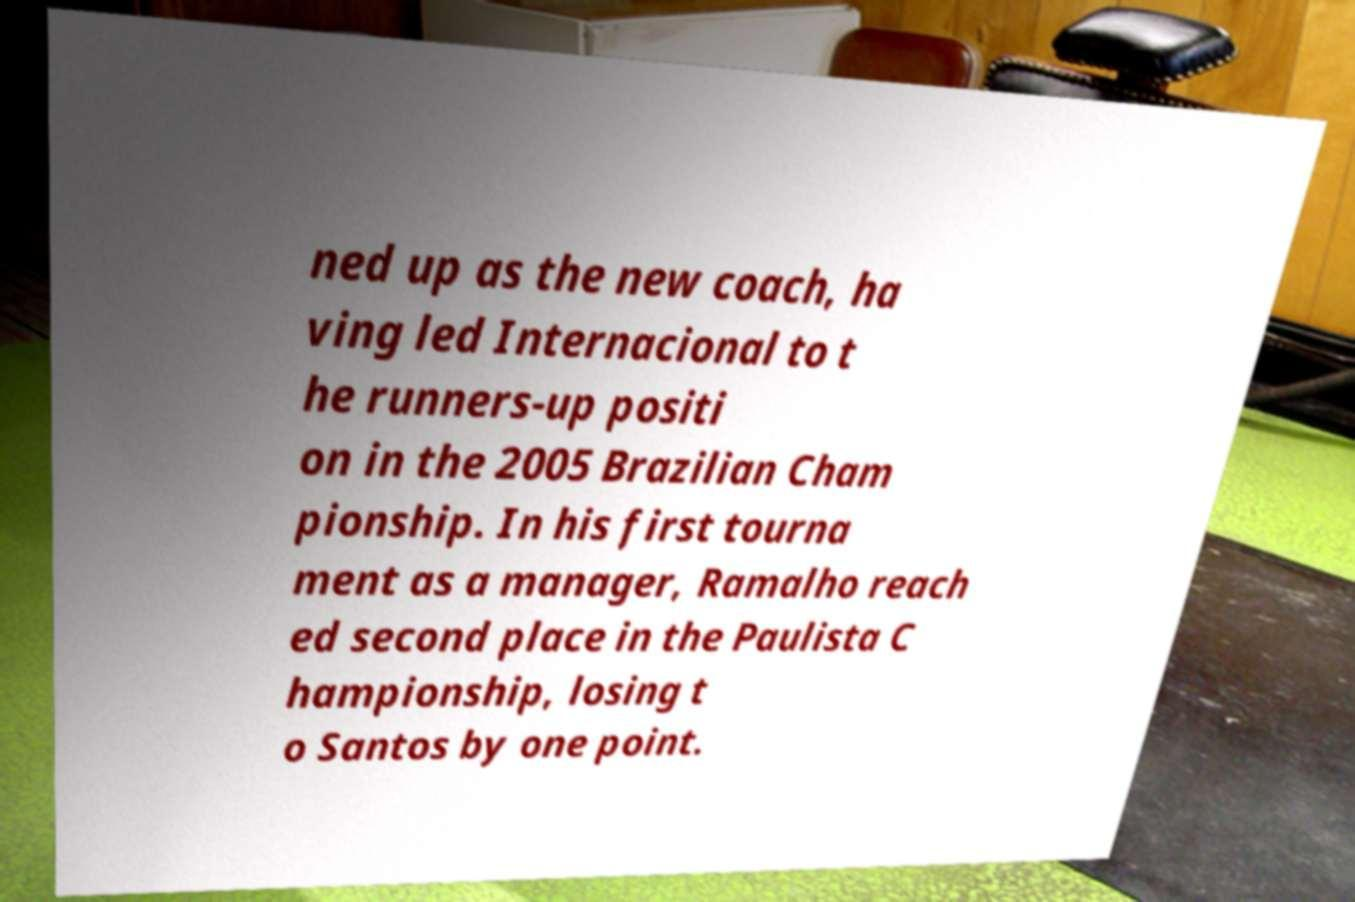Could you extract and type out the text from this image? ned up as the new coach, ha ving led Internacional to t he runners-up positi on in the 2005 Brazilian Cham pionship. In his first tourna ment as a manager, Ramalho reach ed second place in the Paulista C hampionship, losing t o Santos by one point. 